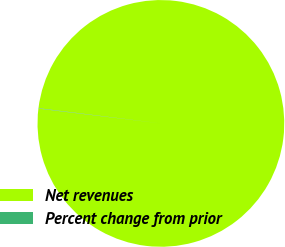Convert chart. <chart><loc_0><loc_0><loc_500><loc_500><pie_chart><fcel>Net revenues<fcel>Percent change from prior<nl><fcel>99.95%<fcel>0.05%<nl></chart> 